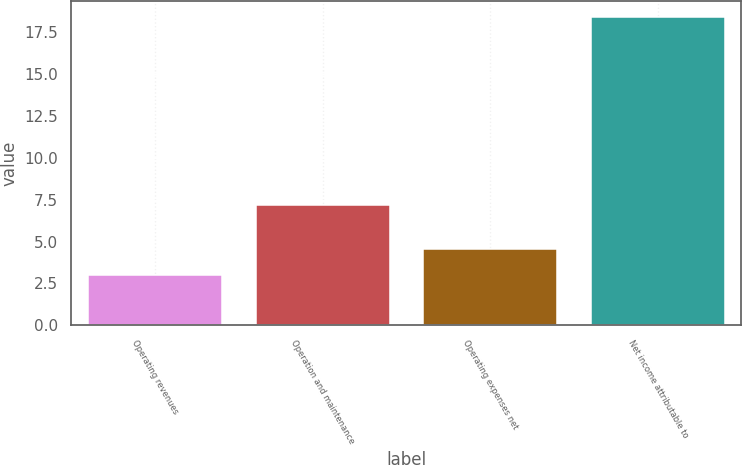<chart> <loc_0><loc_0><loc_500><loc_500><bar_chart><fcel>Operating revenues<fcel>Operation and maintenance<fcel>Operating expenses net<fcel>Net income attributable to<nl><fcel>3<fcel>7.2<fcel>4.54<fcel>18.4<nl></chart> 